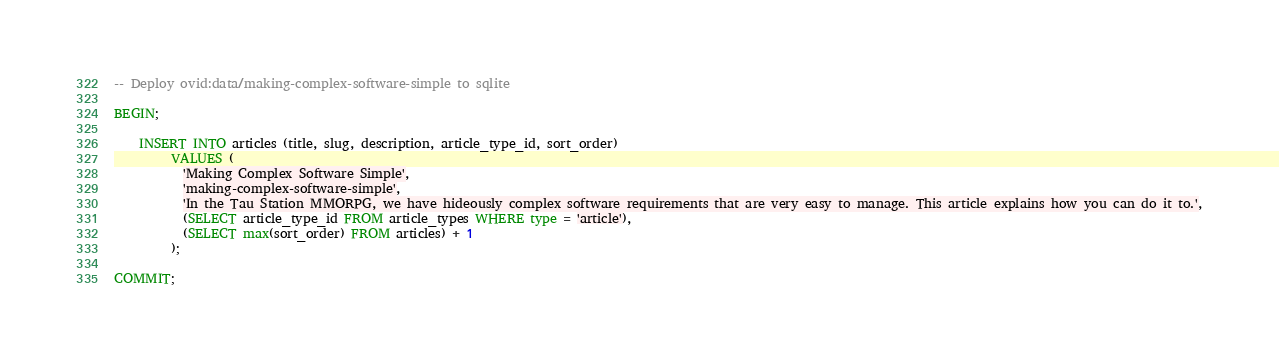Convert code to text. <code><loc_0><loc_0><loc_500><loc_500><_SQL_>-- Deploy ovid:data/making-complex-software-simple to sqlite

BEGIN;

    INSERT INTO articles (title, slug, description, article_type_id, sort_order)
         VALUES (
           'Making Complex Software Simple',
           'making-complex-software-simple',
           'In the Tau Station MMORPG, we have hideously complex software requirements that are very easy to manage. This article explains how you can do it to.',
           (SELECT article_type_id FROM article_types WHERE type = 'article'),
           (SELECT max(sort_order) FROM articles) + 1 
         );

COMMIT;
</code> 